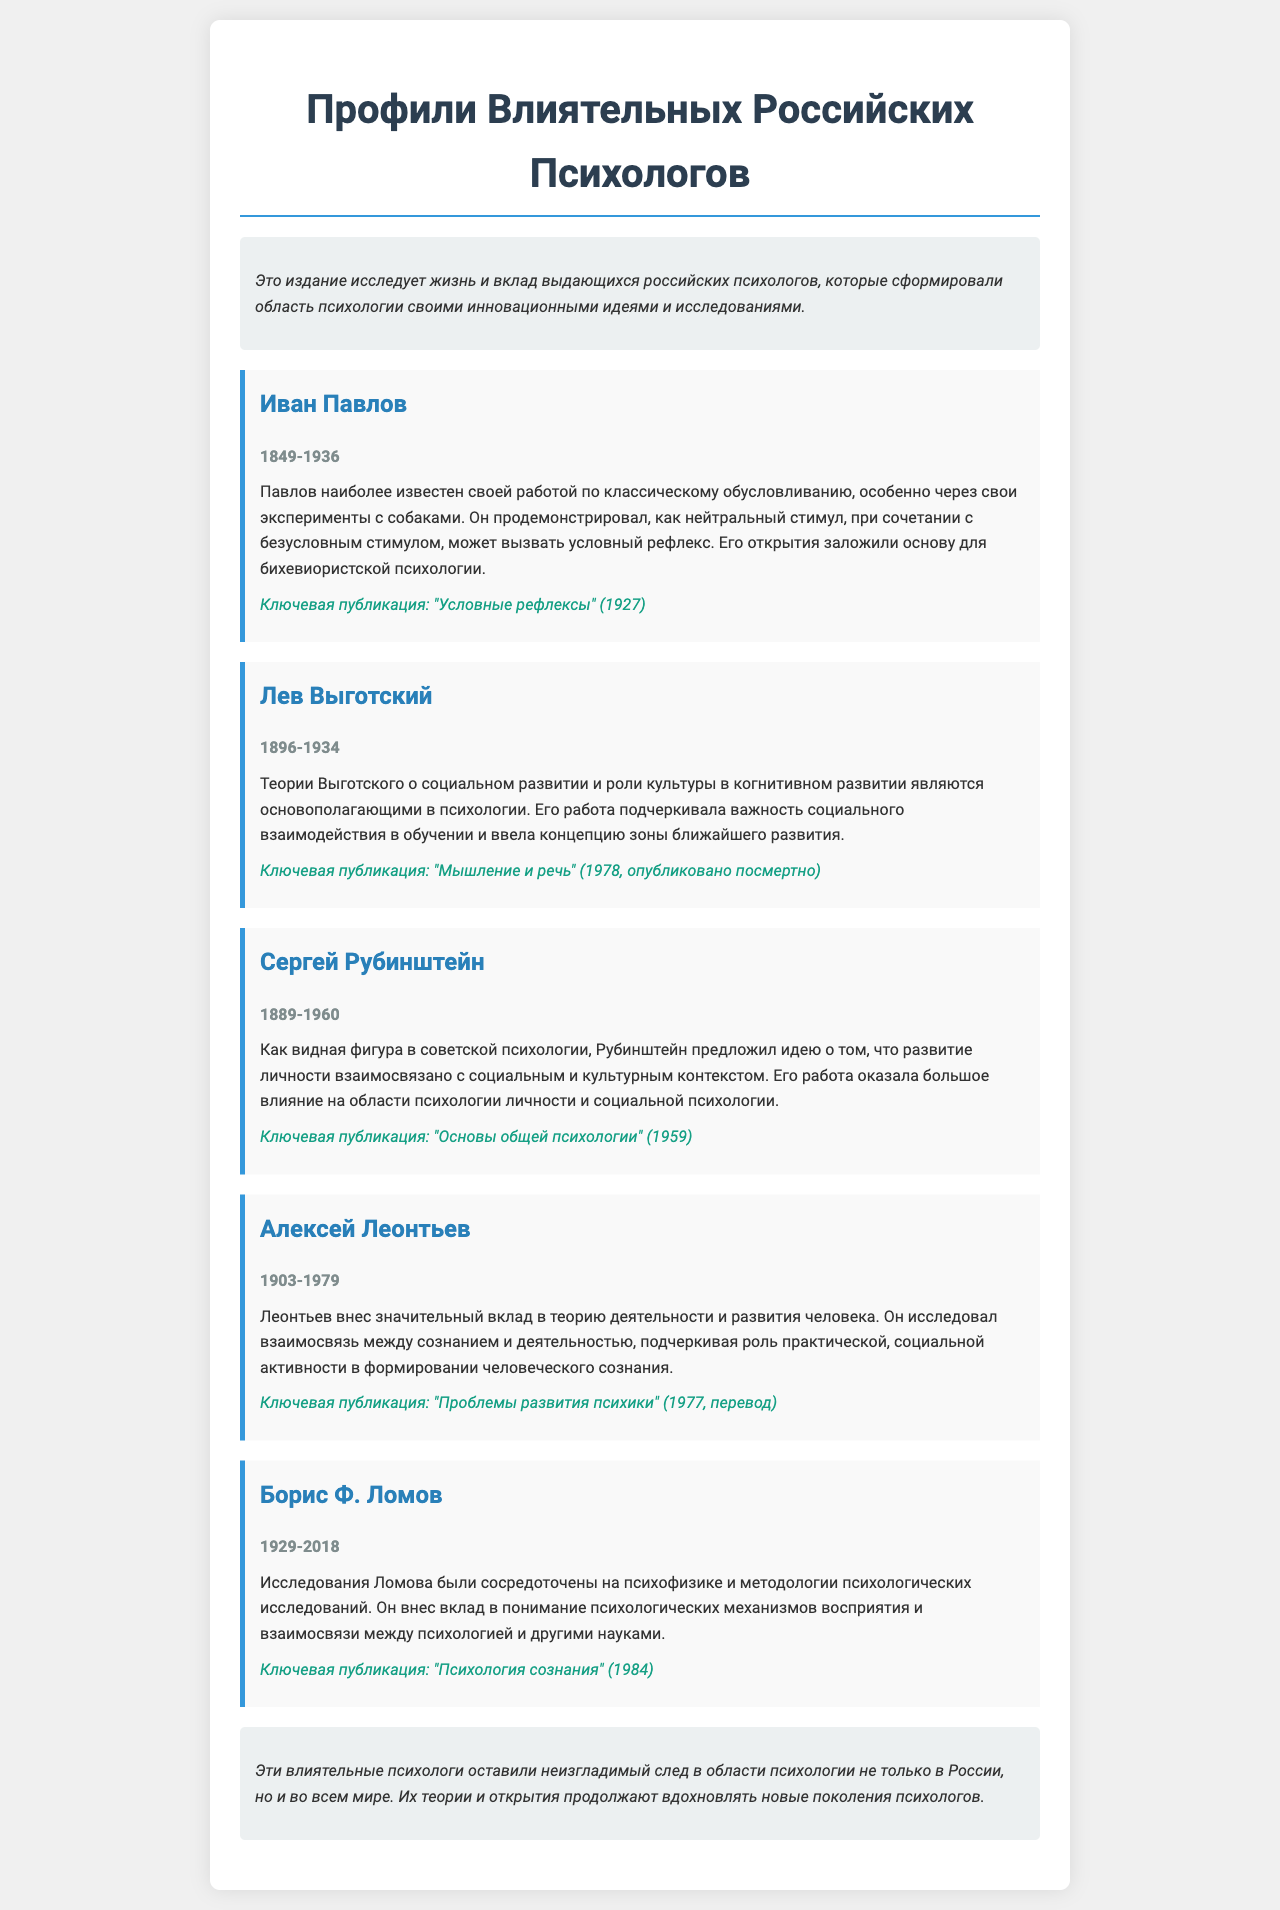Кто является автором работы "Условные рефлексы"? Это ключевая публикация Ивана Павлова, упомянутая в документе.
Answer: Иван Павлов Когда жил Лев Выготский? В документе указаны годы жизни Выготского, что помогает ответить на вопрос.
Answer: 1896-1934 Какой вклад сделал Сергей Рубинштейн? В документе описывается его идея о взаимосвязи развития личности и социального контекста.
Answer: Развитие личности Каково полное название ключевой публикации Бориса Ф. Ломова? В документе указано название его ключевой работы, что дает ответ на вопрос.
Answer: Психология сознания Что общего у идей Павлова и Леонтьева? Оба психолога внесли значительный вклад в понимание механизмов психологии, хотя и с разных точек зрения.
Answer: Механизмы психологии Какую концепцию ввел Лев Выготский? В документе говорится о его концепции, что позволяет ответить на вопрос.
Answer: Зона ближайшего развития Какой стиль оформления использован в документе? Это издание использует стиль с ясными заголовками и структурированными профилями психологов.
Answer: Структурированный стиль Сколько лет прожил Борис Ф. Ломов? Его годы жизни указаны в документе, и это позволяет рассчитать продолжительность жизни.
Answer: 89 лет 